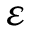<formula> <loc_0><loc_0><loc_500><loc_500>\varepsilon</formula> 